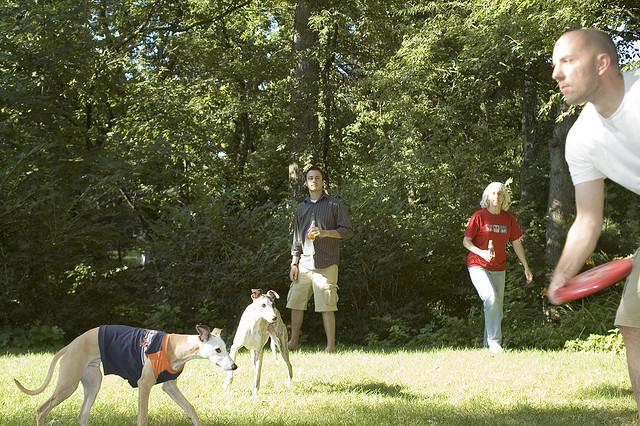Do the individuals in this picture appear to be working?
Be succinct. No. Is the man playing with the dogs?
Be succinct. Yes. What color is the Frisbee in the man's hand?
Give a very brief answer. Red. 